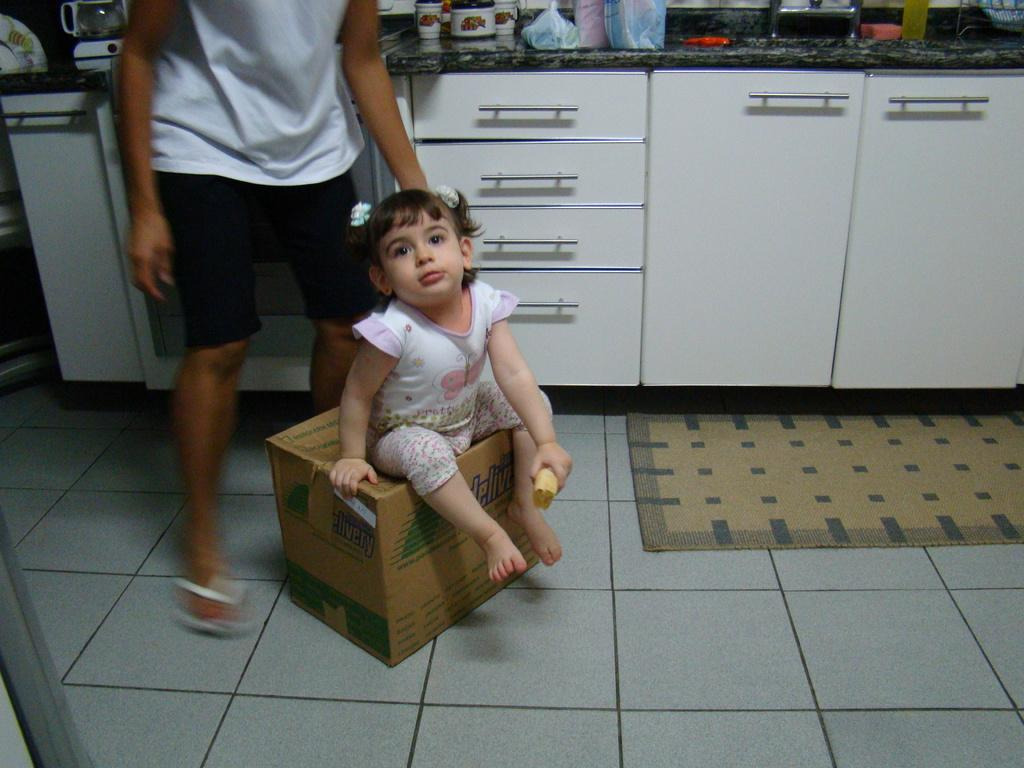<image>
Summarize the visual content of the image. A little girl sitting half in a box that says Delivery in green. 